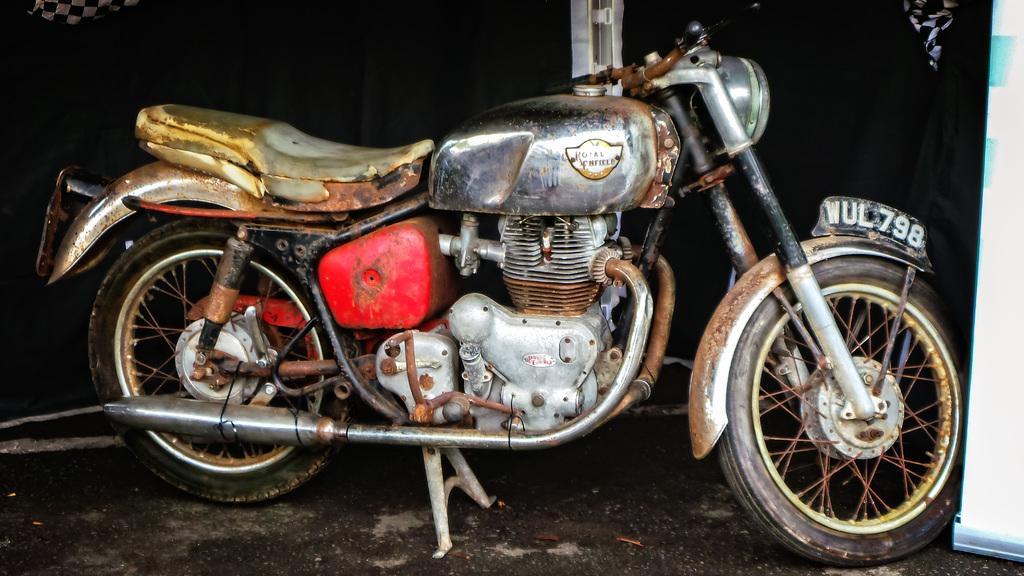Can you describe this image briefly? In this image in the center there is a bike and on the right side of the image there is a white color object, and in the background it looks like a curtain and some clothes and there is a pole in the center. At the bottom there is a walkway. 